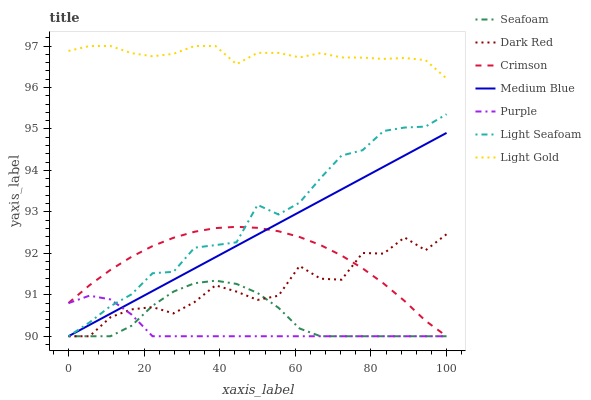Does Purple have the minimum area under the curve?
Answer yes or no. Yes. Does Light Gold have the maximum area under the curve?
Answer yes or no. Yes. Does Dark Red have the minimum area under the curve?
Answer yes or no. No. Does Dark Red have the maximum area under the curve?
Answer yes or no. No. Is Medium Blue the smoothest?
Answer yes or no. Yes. Is Dark Red the roughest?
Answer yes or no. Yes. Is Dark Red the smoothest?
Answer yes or no. No. Is Medium Blue the roughest?
Answer yes or no. No. Does Purple have the lowest value?
Answer yes or no. Yes. Does Light Gold have the lowest value?
Answer yes or no. No. Does Light Gold have the highest value?
Answer yes or no. Yes. Does Dark Red have the highest value?
Answer yes or no. No. Is Light Seafoam less than Light Gold?
Answer yes or no. Yes. Is Light Gold greater than Medium Blue?
Answer yes or no. Yes. Does Purple intersect Crimson?
Answer yes or no. Yes. Is Purple less than Crimson?
Answer yes or no. No. Is Purple greater than Crimson?
Answer yes or no. No. Does Light Seafoam intersect Light Gold?
Answer yes or no. No. 